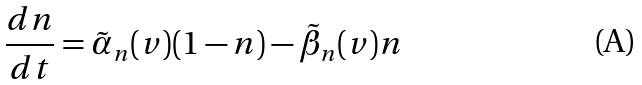Convert formula to latex. <formula><loc_0><loc_0><loc_500><loc_500>\frac { d n } { d t } = \tilde { \alpha } _ { n } ( v ) ( 1 - n ) - \tilde { \beta } _ { n } ( v ) n</formula> 